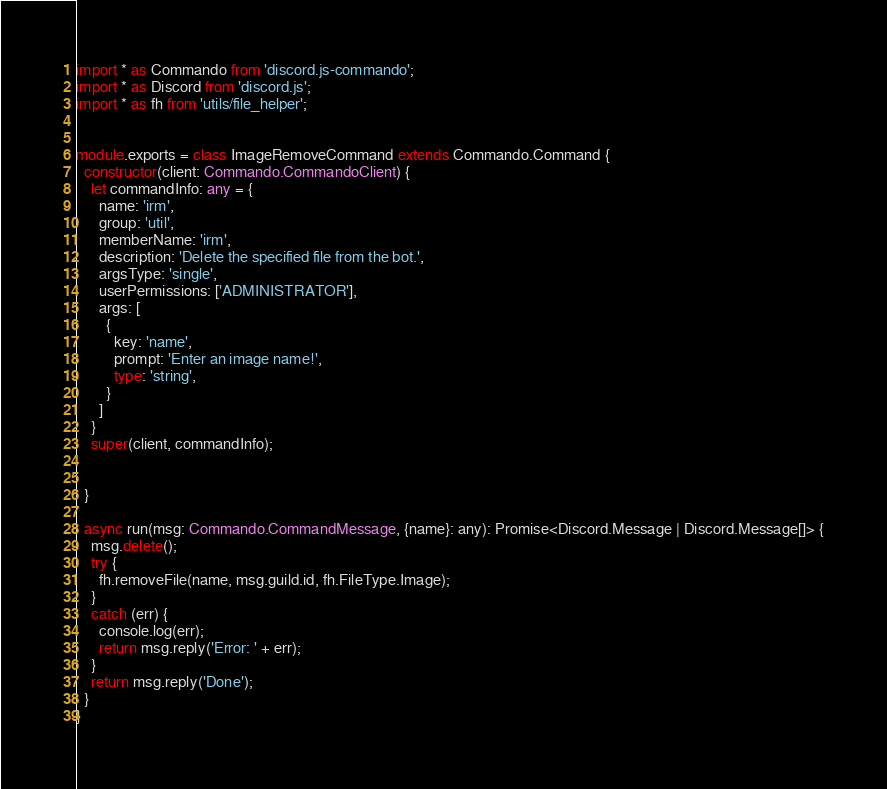<code> <loc_0><loc_0><loc_500><loc_500><_TypeScript_>import * as Commando from 'discord.js-commando';
import * as Discord from 'discord.js';
import * as fh from 'utils/file_helper';


module.exports = class ImageRemoveCommand extends Commando.Command {
  constructor(client: Commando.CommandoClient) {
    let commandInfo: any = {
      name: 'irm',
      group: 'util',
      memberName: 'irm',
      description: 'Delete the specified file from the bot.',
      argsType: 'single',
      userPermissions: ['ADMINISTRATOR'],
      args: [
        {
          key: 'name',
          prompt: 'Enter an image name!',
          type: 'string',
        }
      ]
    }
    super(client, commandInfo);


  }

  async run(msg: Commando.CommandMessage, {name}: any): Promise<Discord.Message | Discord.Message[]> {
    msg.delete();
    try {
      fh.removeFile(name, msg.guild.id, fh.FileType.Image);
    }
    catch (err) {
      console.log(err);
      return msg.reply('Error: ' + err);
    }
    return msg.reply('Done');
  }
}
</code> 